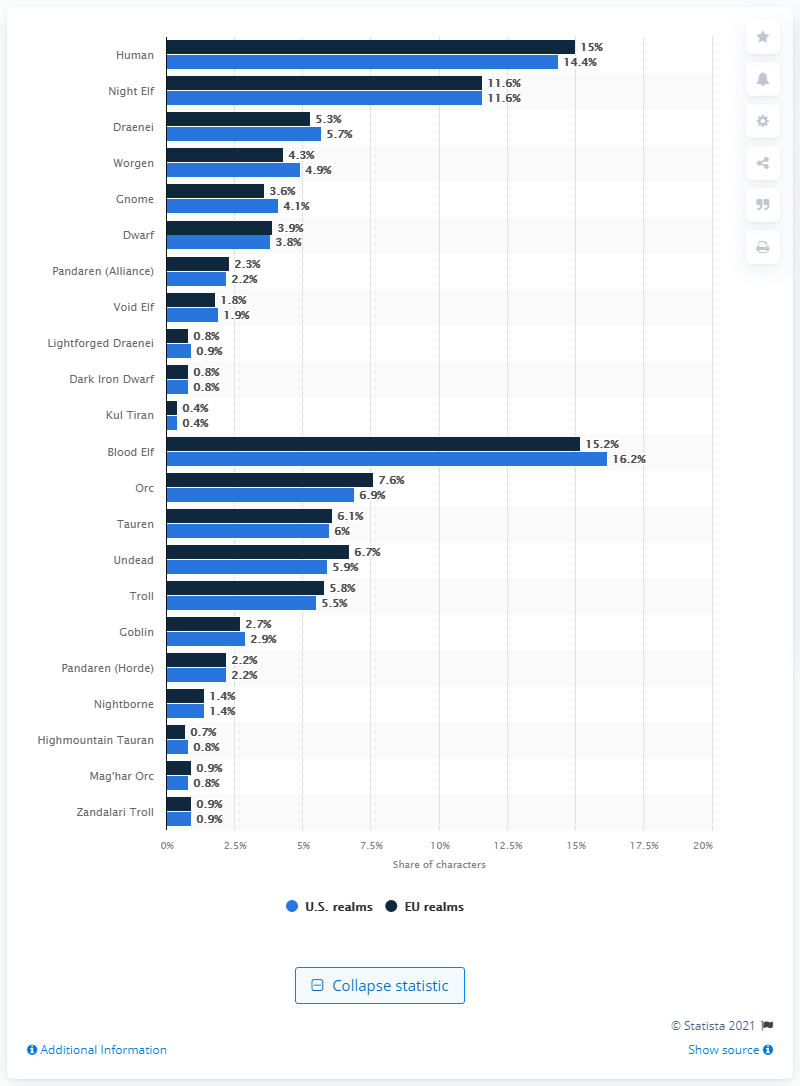Identify some key points in this picture. According to recent data, a significant portion of characters in the U.S. are Worgen. Specifically, 4.9% of all characters in the U.S. are Worgen. 